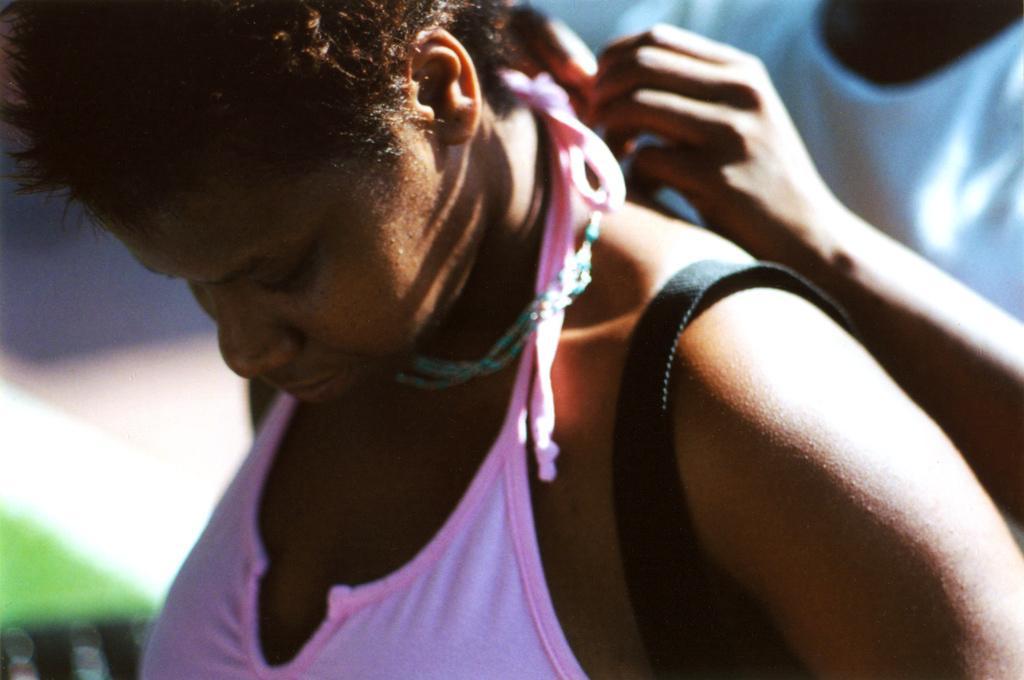Describe this image in one or two sentences. In this image we can see two persons wearing pink and white color dress a person wearing white color dress tying something to the person who is wearing pink color dress and she is also carrying bag. 